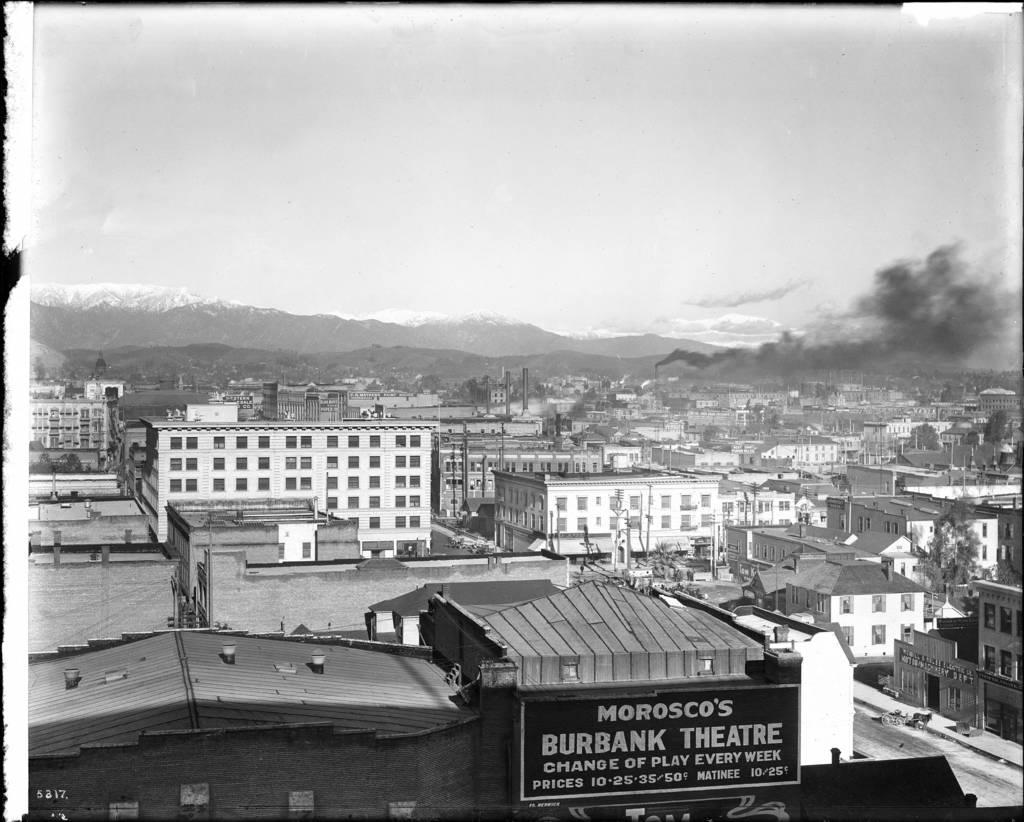What type of structures can be seen in the image? There are buildings in the image, including a factory. Can you describe the activity happening at the factory? Smoke is coming out of the factory, which suggests that it is in operation. What is the color scheme of the image? The image is in black and white color. What type of jeans is the rat wearing in the image? There is no rat or jeans present in the image. How does the factory contribute to the knowledge of the people in the image? The image does not provide information about the knowledge of the people or the factory's impact on it. 